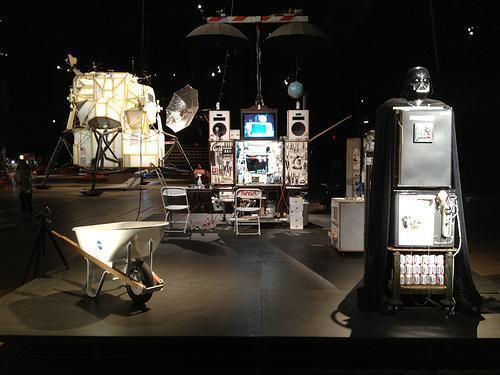How many wheels does the wheelbarrow have?
Give a very brief answer. 1. 